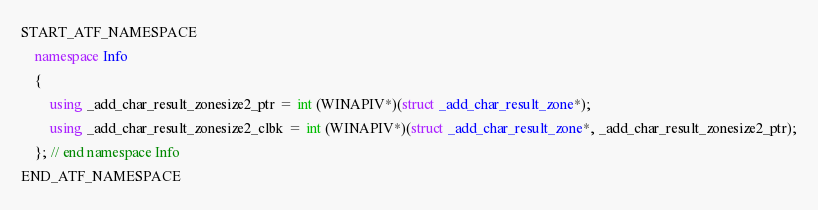Convert code to text. <code><loc_0><loc_0><loc_500><loc_500><_C++_>

START_ATF_NAMESPACE
    namespace Info
    {
        using _add_char_result_zonesize2_ptr = int (WINAPIV*)(struct _add_char_result_zone*);
        using _add_char_result_zonesize2_clbk = int (WINAPIV*)(struct _add_char_result_zone*, _add_char_result_zonesize2_ptr);
    }; // end namespace Info
END_ATF_NAMESPACE
</code> 